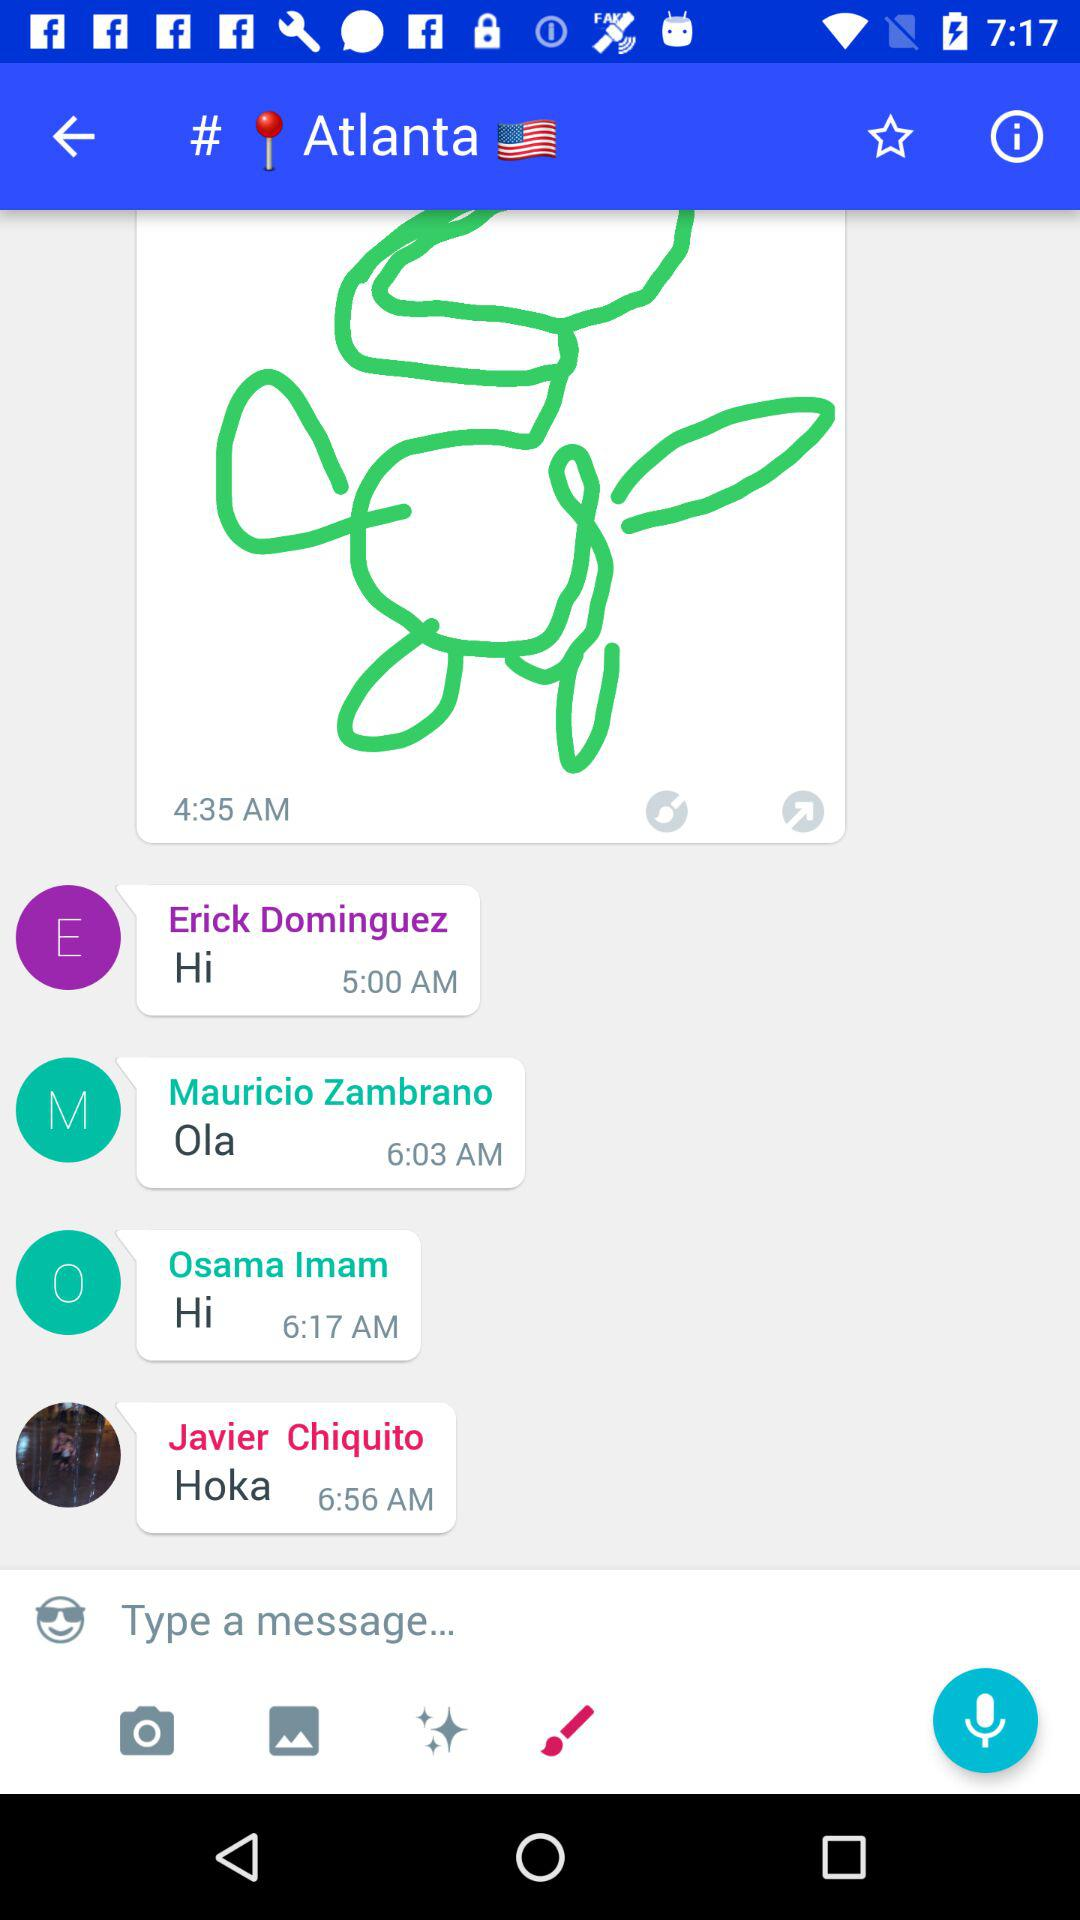How many messages are there in the conversation?
Answer the question using a single word or phrase. 4 